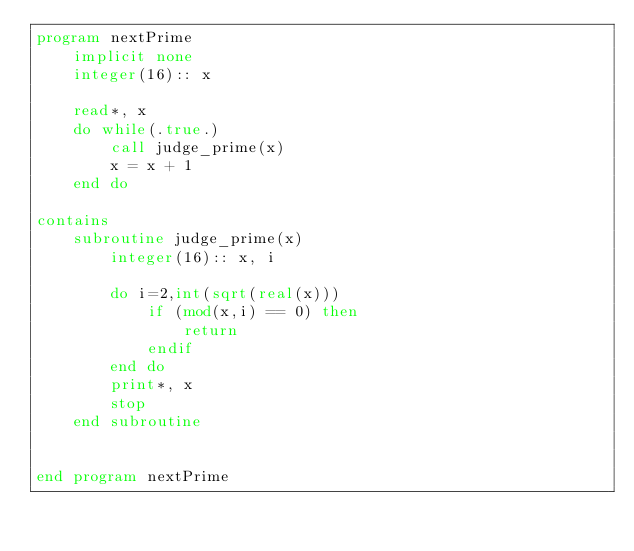Convert code to text. <code><loc_0><loc_0><loc_500><loc_500><_FORTRAN_>program nextPrime
    implicit none
    integer(16):: x

    read*, x
    do while(.true.)
        call judge_prime(x)
        x = x + 1
    end do

contains
    subroutine judge_prime(x)
        integer(16):: x, i

        do i=2,int(sqrt(real(x)))
            if (mod(x,i) == 0) then
                return
            endif
        end do
        print*, x
        stop
    end subroutine


end program nextPrime</code> 